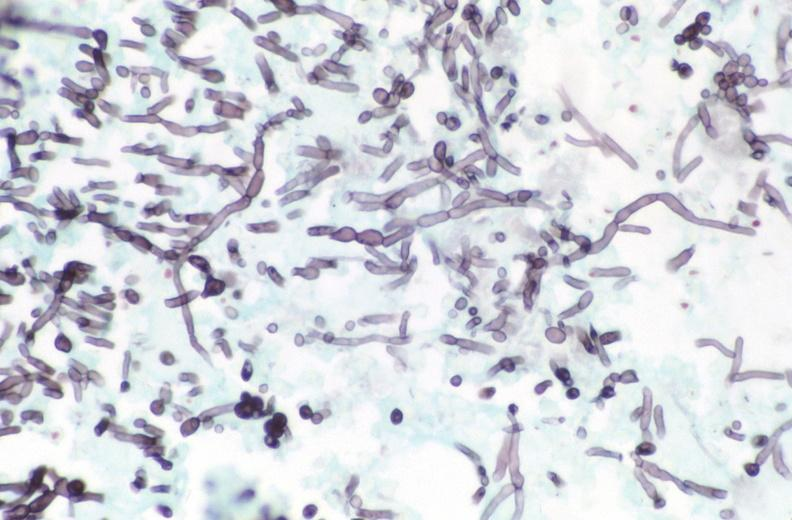what is present?
Answer the question using a single word or phrase. Gastrointestinal 